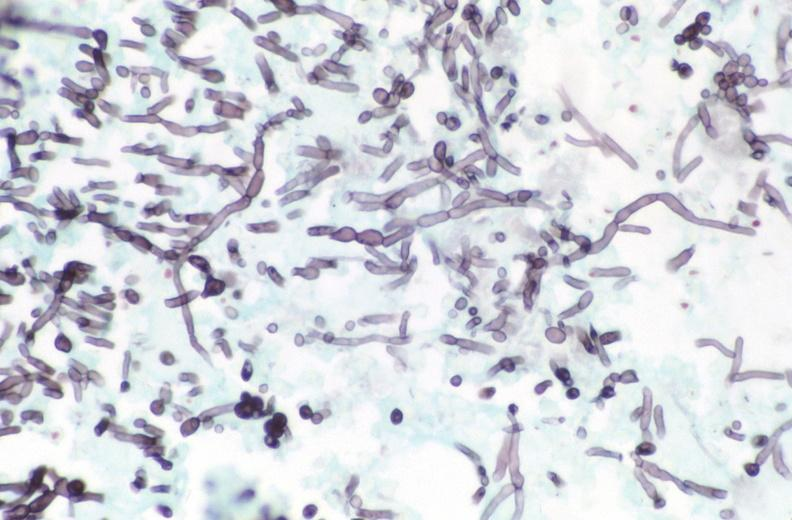what is present?
Answer the question using a single word or phrase. Gastrointestinal 